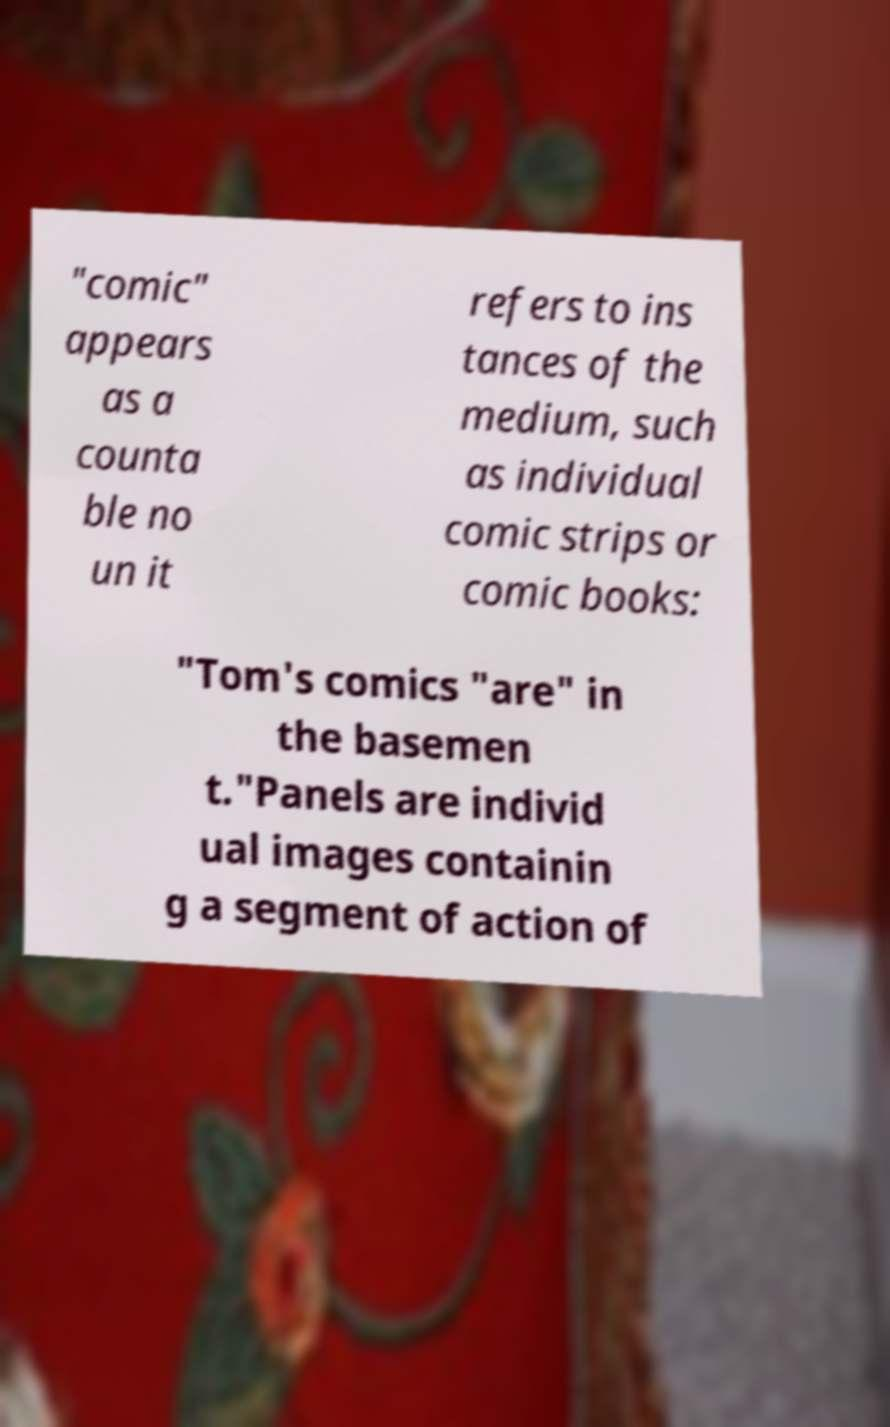Could you assist in decoding the text presented in this image and type it out clearly? "comic" appears as a counta ble no un it refers to ins tances of the medium, such as individual comic strips or comic books: "Tom's comics "are" in the basemen t."Panels are individ ual images containin g a segment of action of 